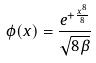Convert formula to latex. <formula><loc_0><loc_0><loc_500><loc_500>\phi ( x ) = \frac { e ^ { + \frac { x ^ { 8 } } { 8 } } } { \sqrt { 8 \beta } }</formula> 